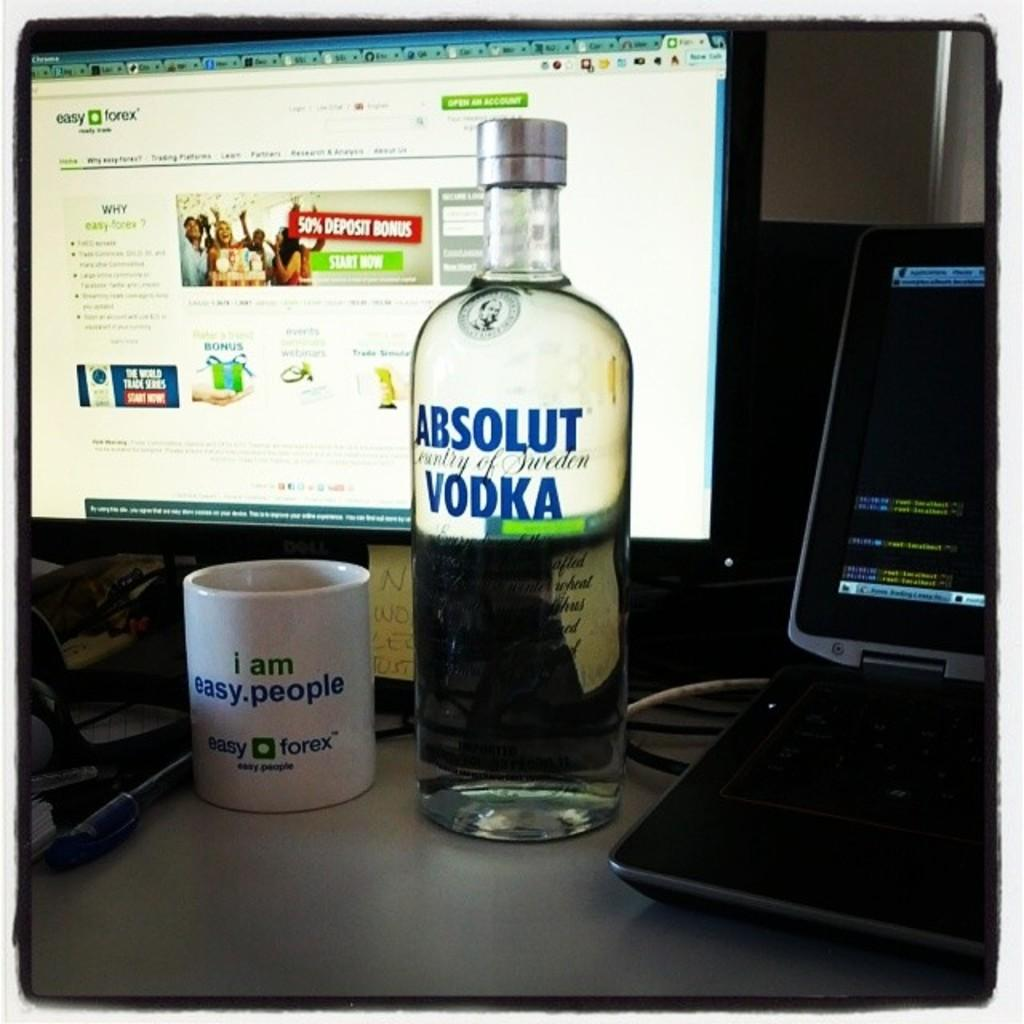<image>
Give a short and clear explanation of the subsequent image. A bottle of Absolut vodka sits in front of a computer screen open to the Easy Forex webpage. 